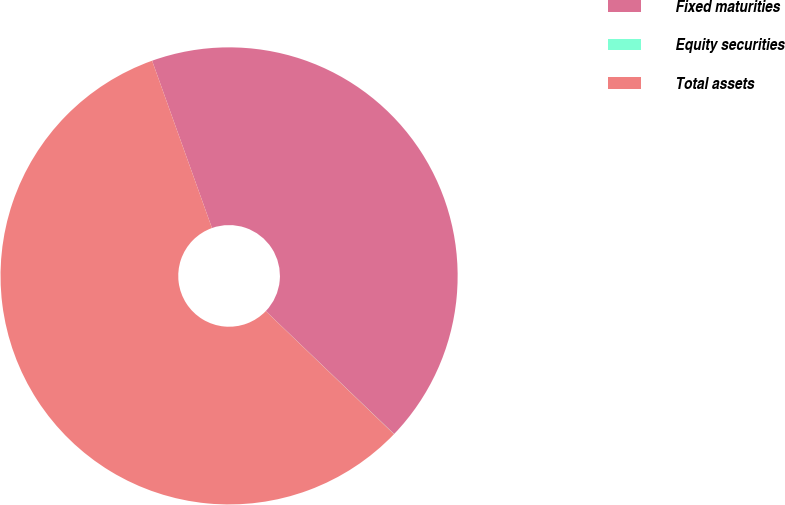<chart> <loc_0><loc_0><loc_500><loc_500><pie_chart><fcel>Fixed maturities<fcel>Equity securities<fcel>Total assets<nl><fcel>42.63%<fcel>0.01%<fcel>57.36%<nl></chart> 